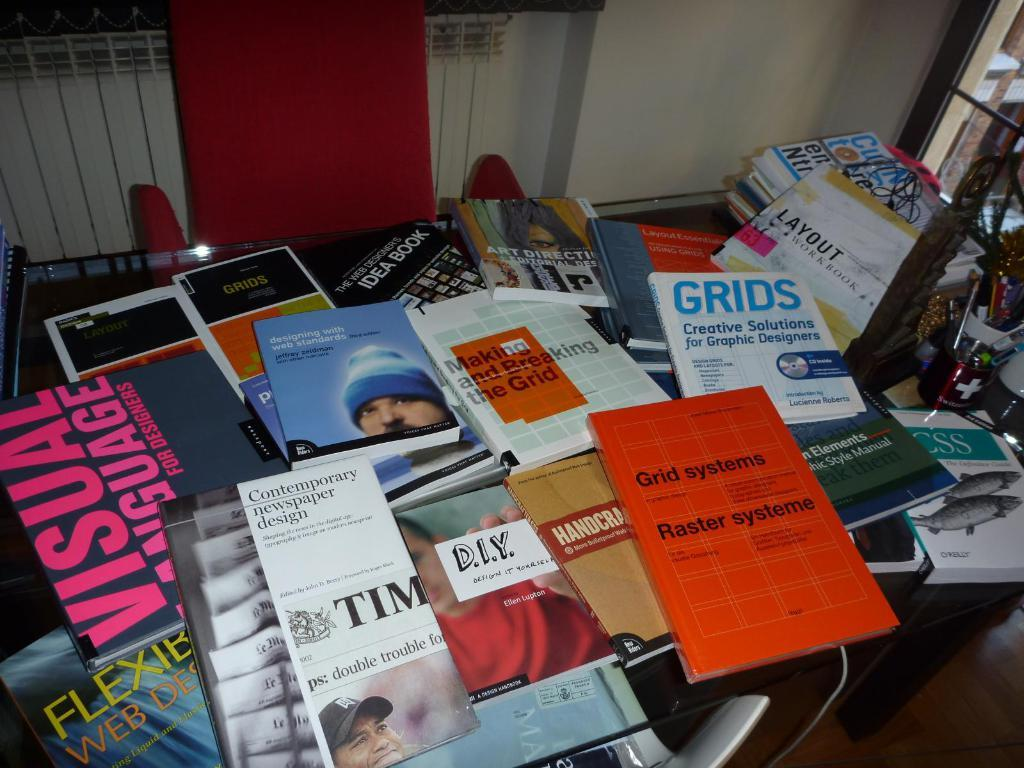<image>
Render a clear and concise summary of the photo. A pile of magazines are visible with one titled Grids, creative solutions for graphic designers., 